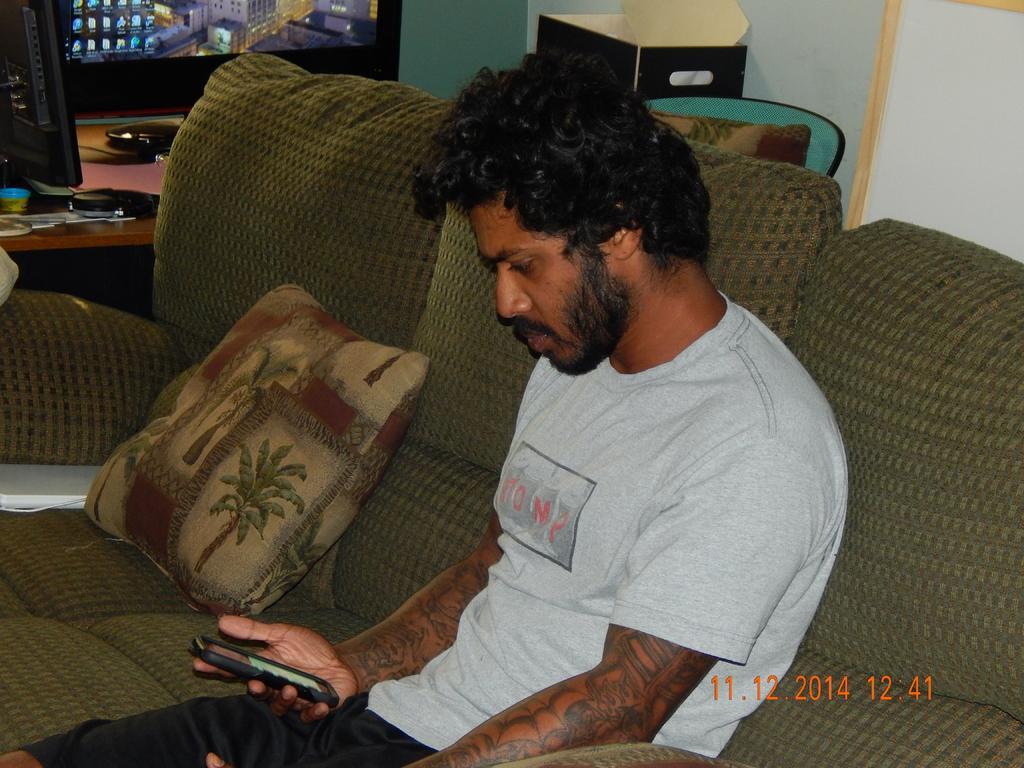How would you summarize this image in a sentence or two? In this image I can see a person sitting on the couch and holding mobile. To the right of him there are some objects and the system on the table. 